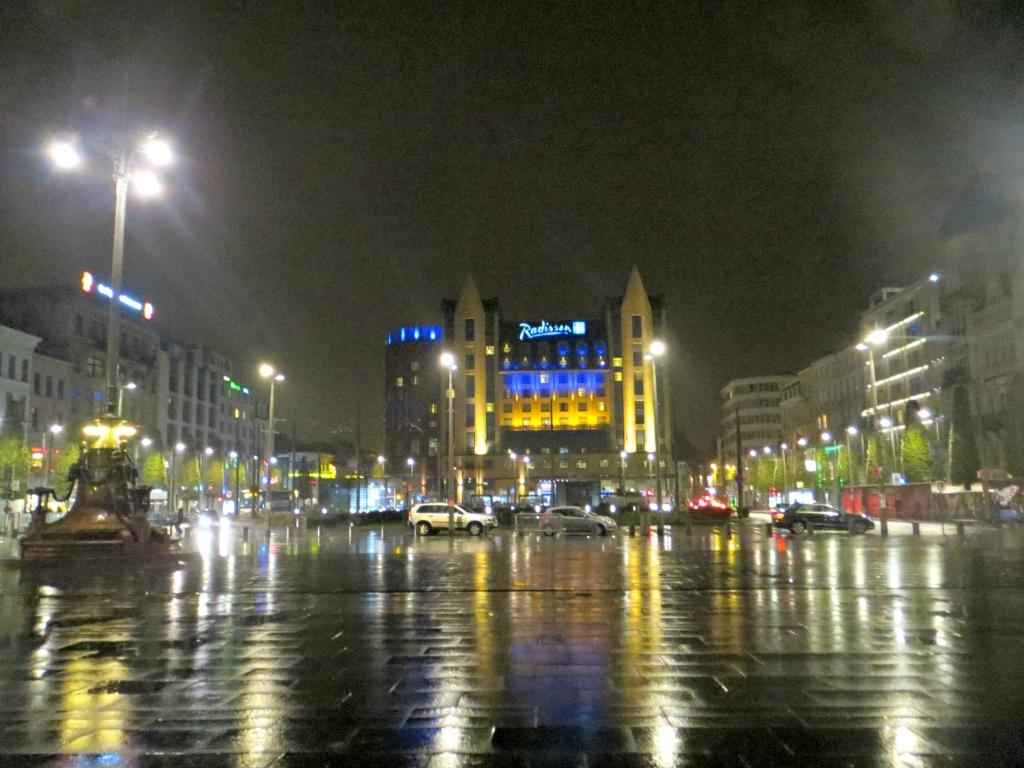What type of structures can be seen in the image? There are buildings in the image. What else is present in the image besides buildings? There are cars, boards with text, and pole lights visible in the image. What is visible in the sky in the image? The sky is visible in the image. Can you see a plane flying in the image? There is no plane visible in the image. Is there a prison in the image? There is no prison present in the image. 